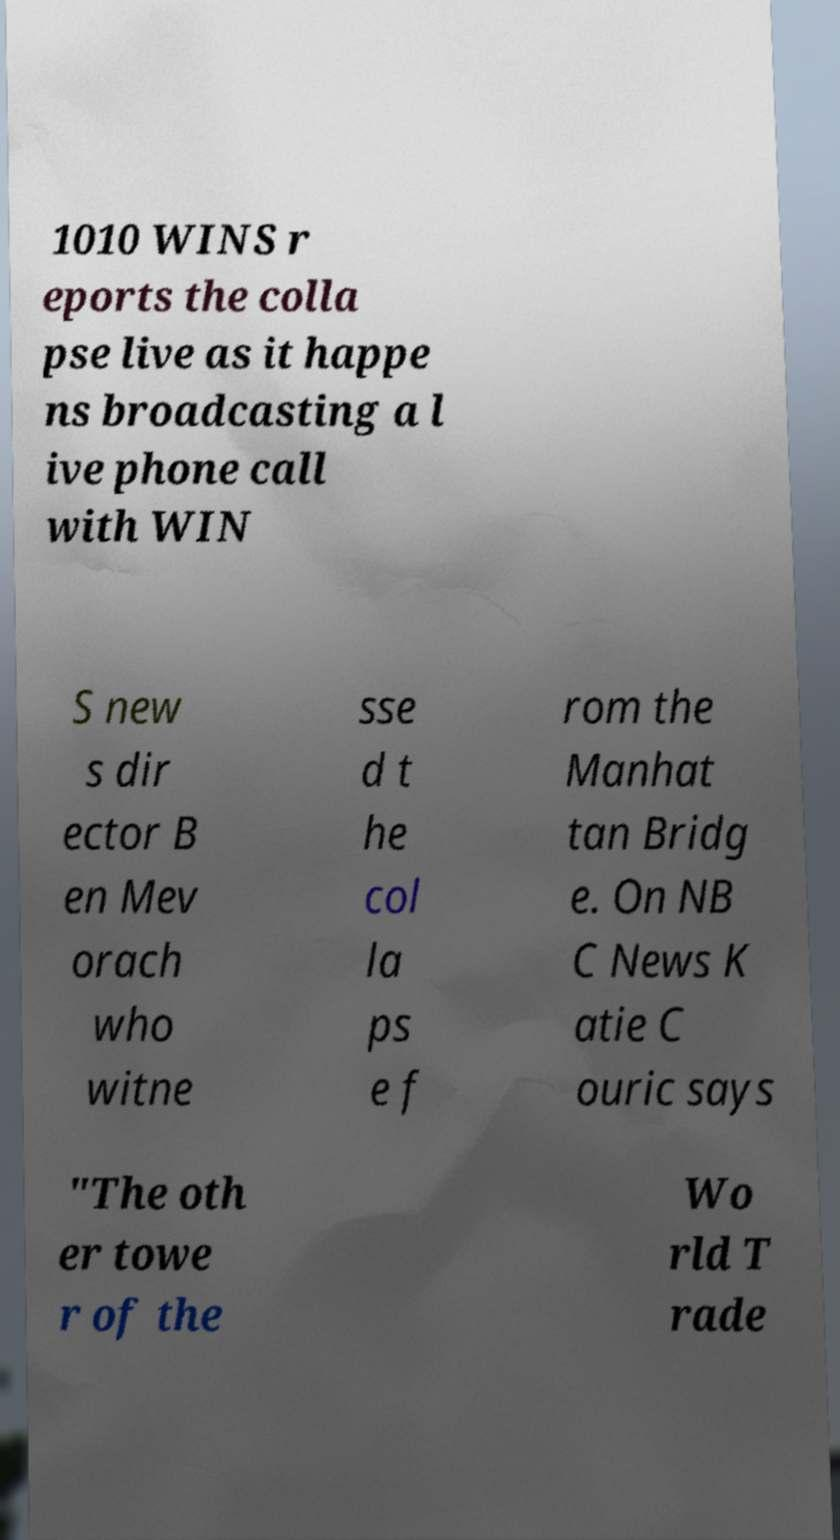For documentation purposes, I need the text within this image transcribed. Could you provide that? 1010 WINS r eports the colla pse live as it happe ns broadcasting a l ive phone call with WIN S new s dir ector B en Mev orach who witne sse d t he col la ps e f rom the Manhat tan Bridg e. On NB C News K atie C ouric says "The oth er towe r of the Wo rld T rade 